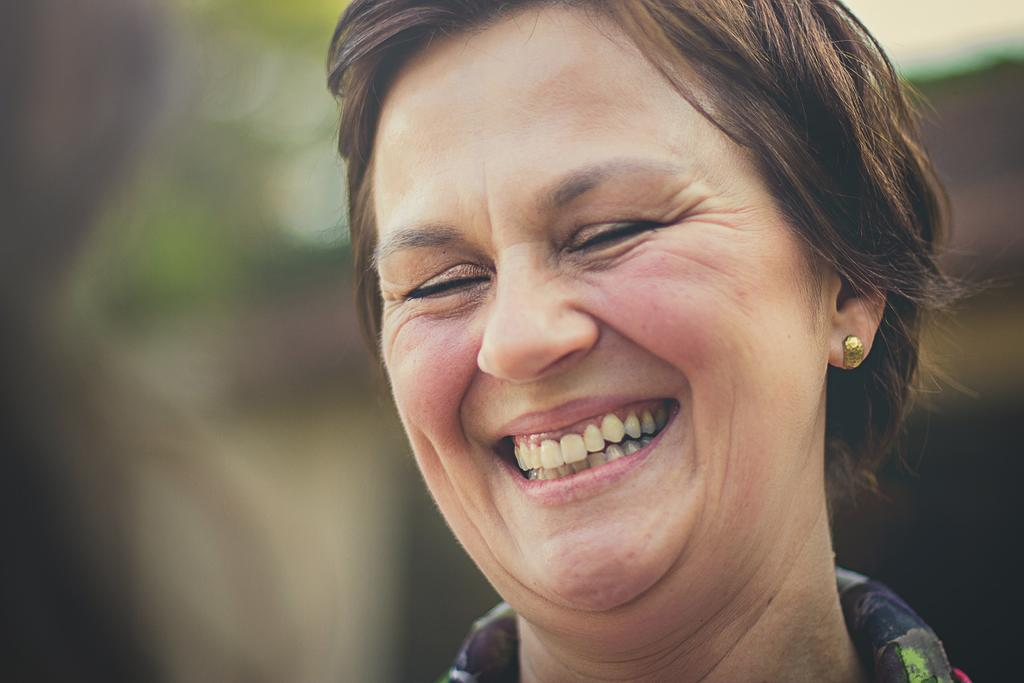What is the main subject of the image? There is a person in the image. How is the person's facial expression in the image? The person has a smiling face. Can you describe the background of the image? The background of the image is blurred. How many kittens are playing with a knife in the background of the image? There are no kittens or knives present in the image; the background is blurred. 